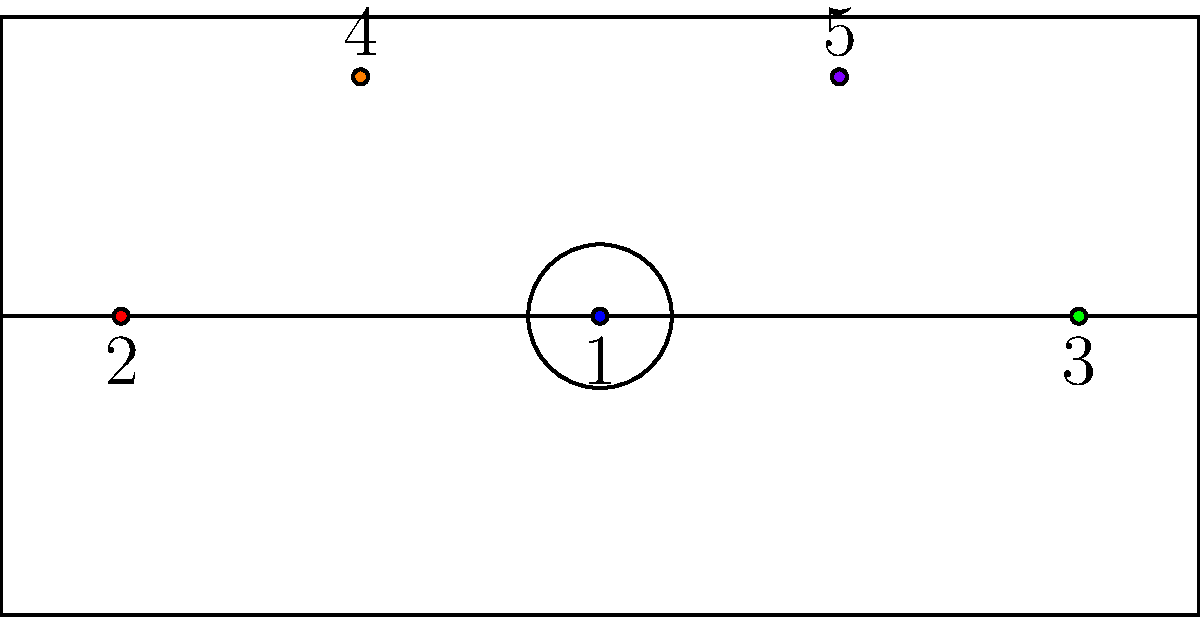In the diagram above, which number represents the position typically responsible for bringing the ball up the court and initiating the offense? To answer this question, let's break down the roles of each position in basketball:

1. Position 1 (Blue dot at center): This is the Point Guard. They are typically responsible for bringing the ball up the court and initiating the offense. They are often the team's best ball-handler and passer.

2. Position 2 (Red dot on left): This is the Shooting Guard. They are usually good shooters and scorers but don't typically initiate the offense.

3. Position 3 (Green dot on right): This is the Small Forward. They are versatile players who can score and defend but aren't primary ball-handlers.

4. Position 4 (Orange dot top left): This is the Power Forward. They play near the basket and are typically strong rebounders.

5. Position 5 (Purple dot top right): This is the Center. They are usually the tallest players and play close to the basket.

Given the question asks about the position responsible for bringing the ball up the court and initiating the offense, the correct answer is Position 1, the Point Guard.
Answer: 1 